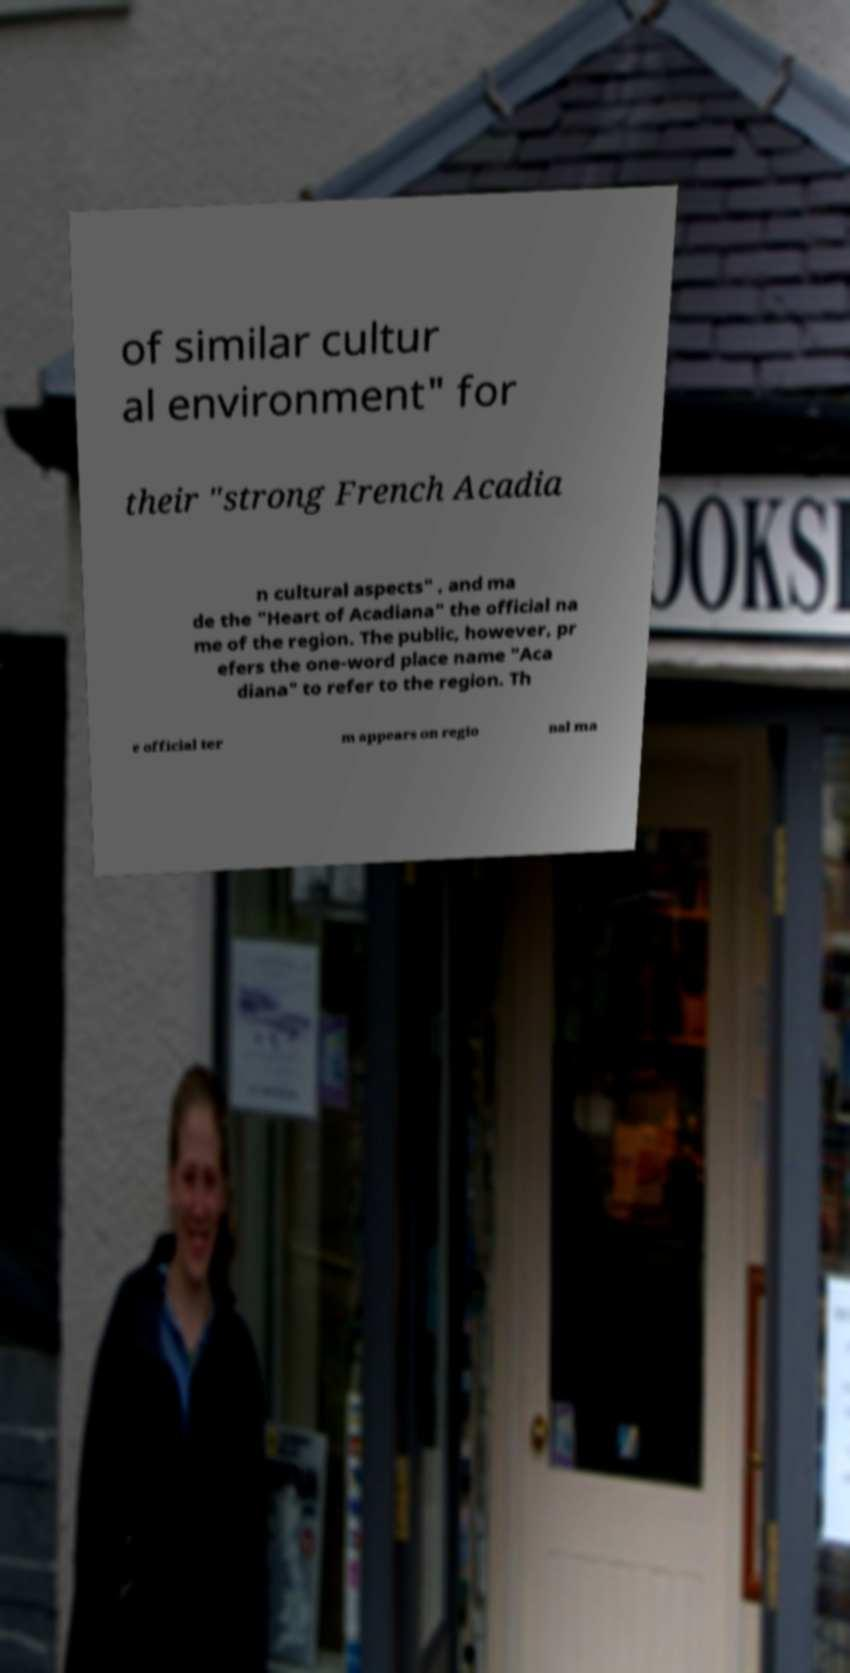Please read and relay the text visible in this image. What does it say? of similar cultur al environment" for their "strong French Acadia n cultural aspects" , and ma de the "Heart of Acadiana" the official na me of the region. The public, however, pr efers the one-word place name "Aca diana" to refer to the region. Th e official ter m appears on regio nal ma 